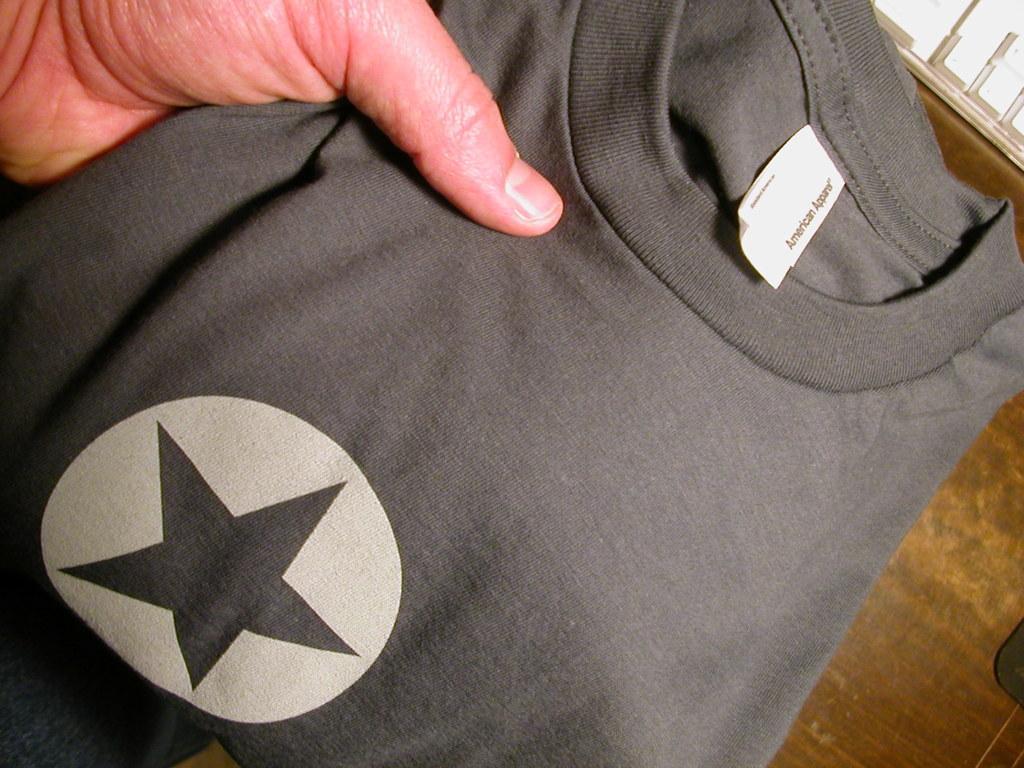In one or two sentences, can you explain what this image depicts? Here we can see a hand of a person holding a t shirt. 